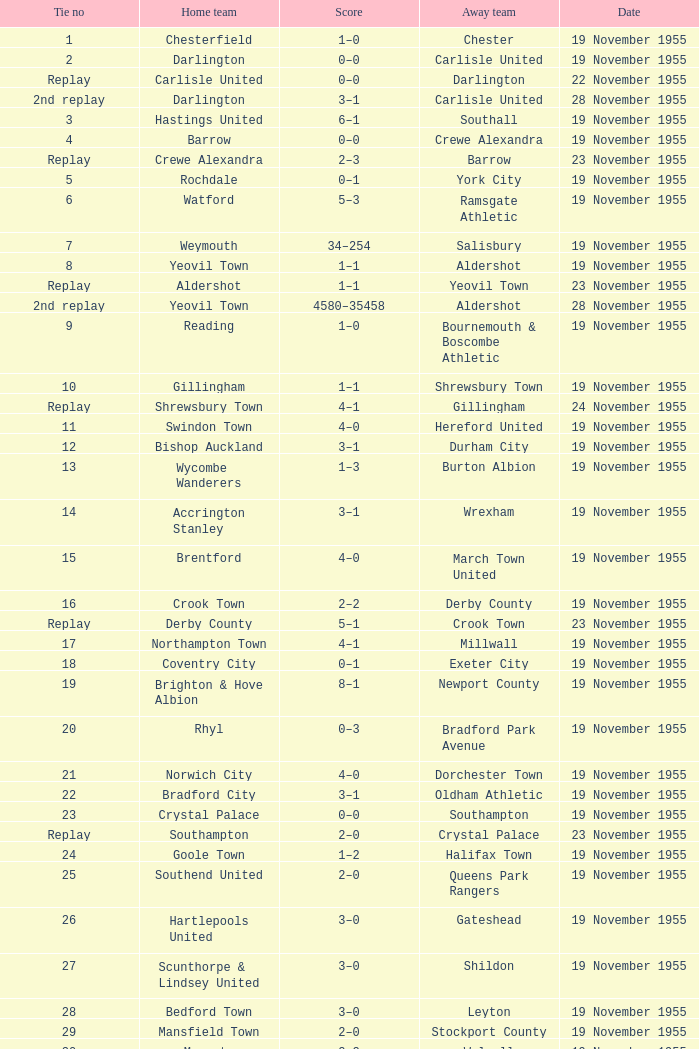What is the date of connection no. 34? 19 November 1955. 